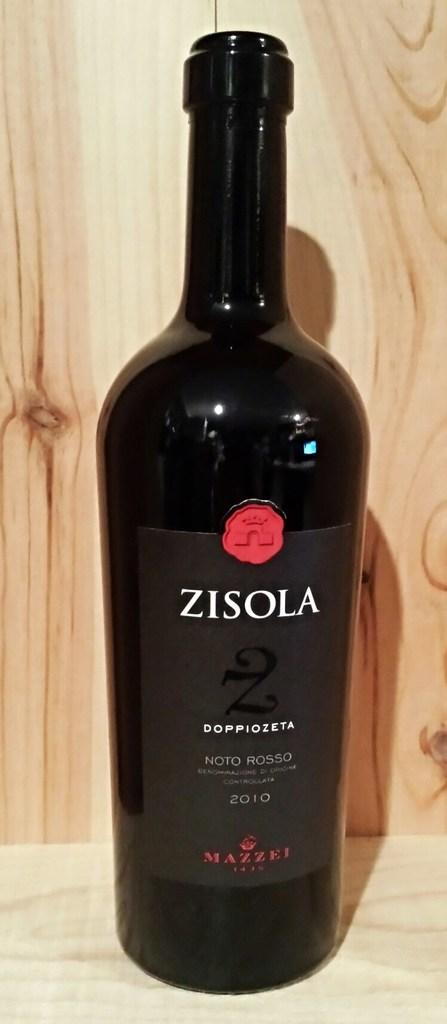<image>
Provide a brief description of the given image. A dark colored bottle of Zisola shown sitting on a wood counter. 